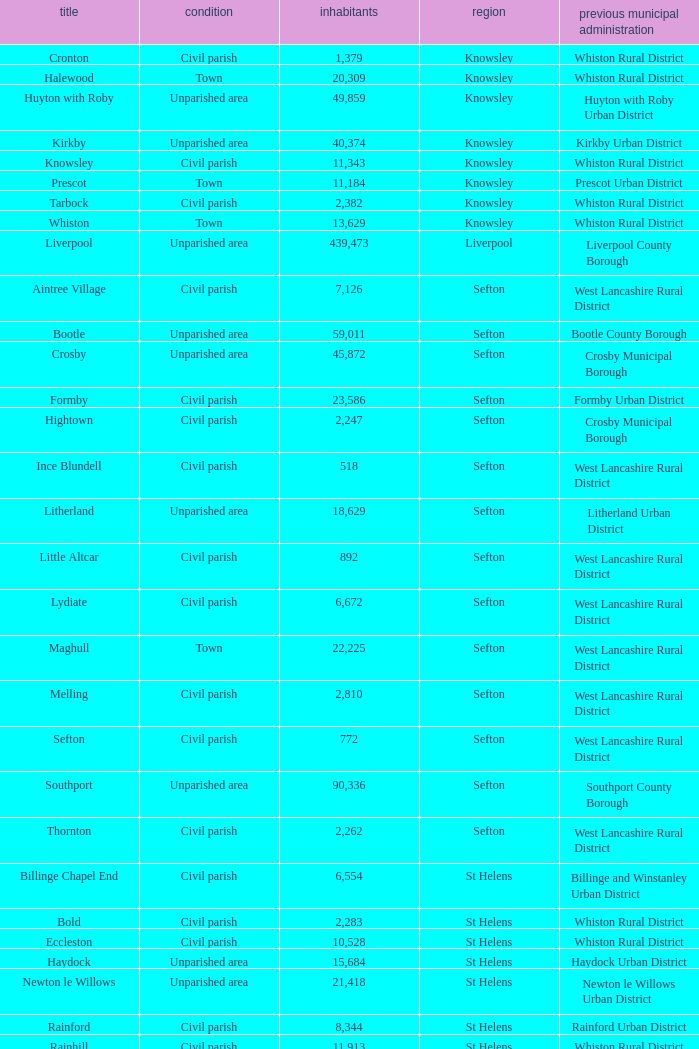What is the district of wallasey Wirral. 